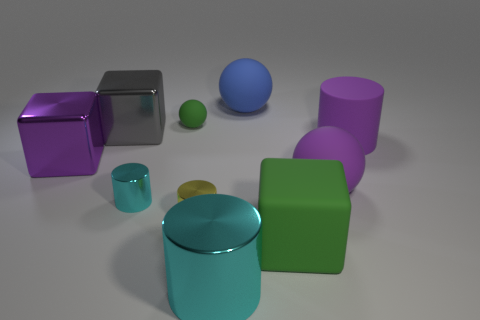Is there a cyan cube made of the same material as the big purple block?
Offer a terse response. No. What color is the other large thing that is the same shape as the big blue rubber thing?
Ensure brevity in your answer.  Purple. Is the material of the big gray object the same as the big cylinder that is on the left side of the big matte cube?
Make the answer very short. Yes. What is the shape of the large object that is behind the matte sphere that is on the left side of the yellow shiny cylinder?
Give a very brief answer. Sphere. Do the cyan thing that is to the left of the green matte sphere and the small yellow cylinder have the same size?
Offer a very short reply. Yes. How many other objects are the same shape as the purple metal object?
Keep it short and to the point. 2. Do the big cylinder in front of the purple shiny thing and the matte cylinder have the same color?
Offer a terse response. No. Are there any tiny metallic things of the same color as the matte cube?
Provide a short and direct response. No. There is a large gray metal object; how many cyan metallic objects are to the left of it?
Keep it short and to the point. 0. What number of other objects are there of the same size as the green cube?
Offer a terse response. 6. 